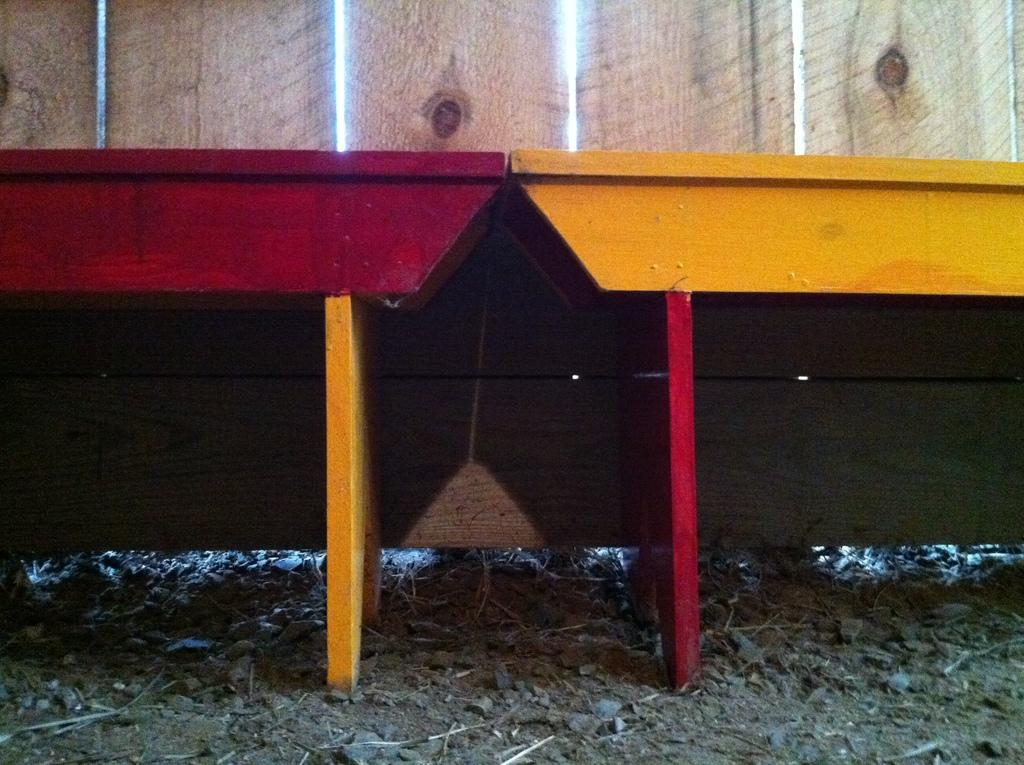What type of material is used for the wall in the image? There is a wooden wall in the image. How many tables can be seen in the image? There are two tables in the image. What colors are the tables? The tables are in red and yellow colors. What is the opinion of the ray about the wooden wall in the image? There is no ray present in the image, and therefore no opinion can be attributed to it. 